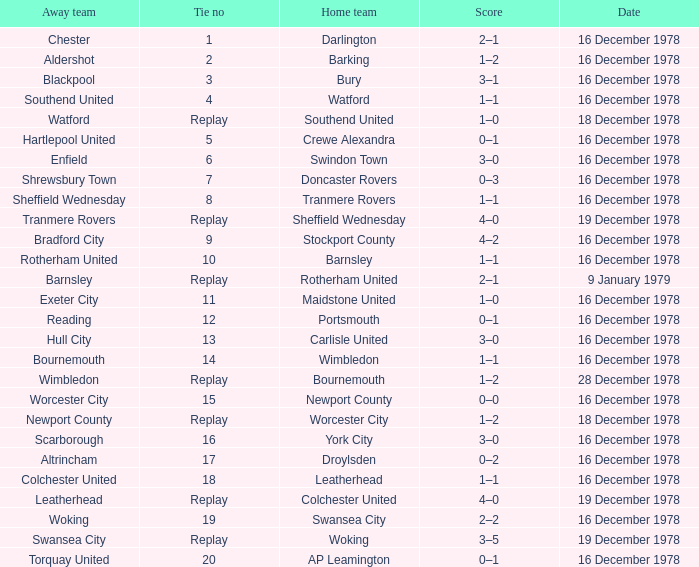What is the tie no for the home team swansea city? 19.0. 